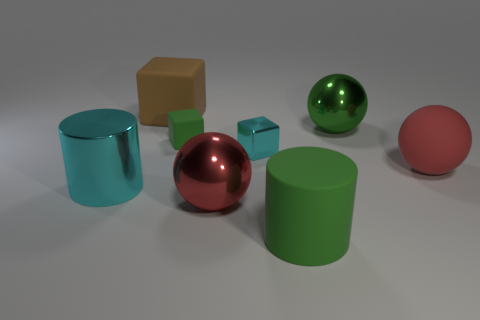Does the large matte sphere on the right side of the tiny green matte cube have the same color as the metallic sphere that is in front of the cyan metallic cylinder?
Make the answer very short. Yes. There is a sphere that is the same color as the small matte block; what material is it?
Your response must be concise. Metal. How many other objects are the same color as the big rubber ball?
Offer a terse response. 1. What number of things are either cubes in front of the brown matte thing or large yellow spheres?
Your response must be concise. 2. Are there fewer large green things that are behind the red matte thing than big green balls in front of the matte cylinder?
Ensure brevity in your answer.  No. Are there any big cyan cylinders left of the cyan cylinder?
Give a very brief answer. No. How many things are matte objects that are behind the rubber cylinder or green objects behind the small green rubber thing?
Your answer should be very brief. 4. What number of cylinders are the same color as the metallic cube?
Keep it short and to the point. 1. What is the color of the metallic thing that is the same shape as the tiny rubber object?
Provide a short and direct response. Cyan. There is a large object that is behind the small cyan object and to the right of the small rubber thing; what shape is it?
Offer a terse response. Sphere. 